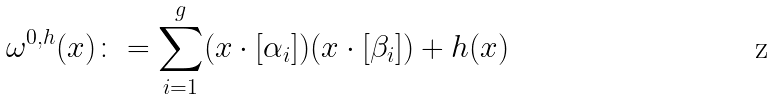Convert formula to latex. <formula><loc_0><loc_0><loc_500><loc_500>\omega ^ { 0 , h } ( x ) \colon = \sum ^ { g } _ { i = 1 } ( x \cdot [ \alpha _ { i } ] ) ( x \cdot [ \beta _ { i } ] ) + h ( x )</formula> 